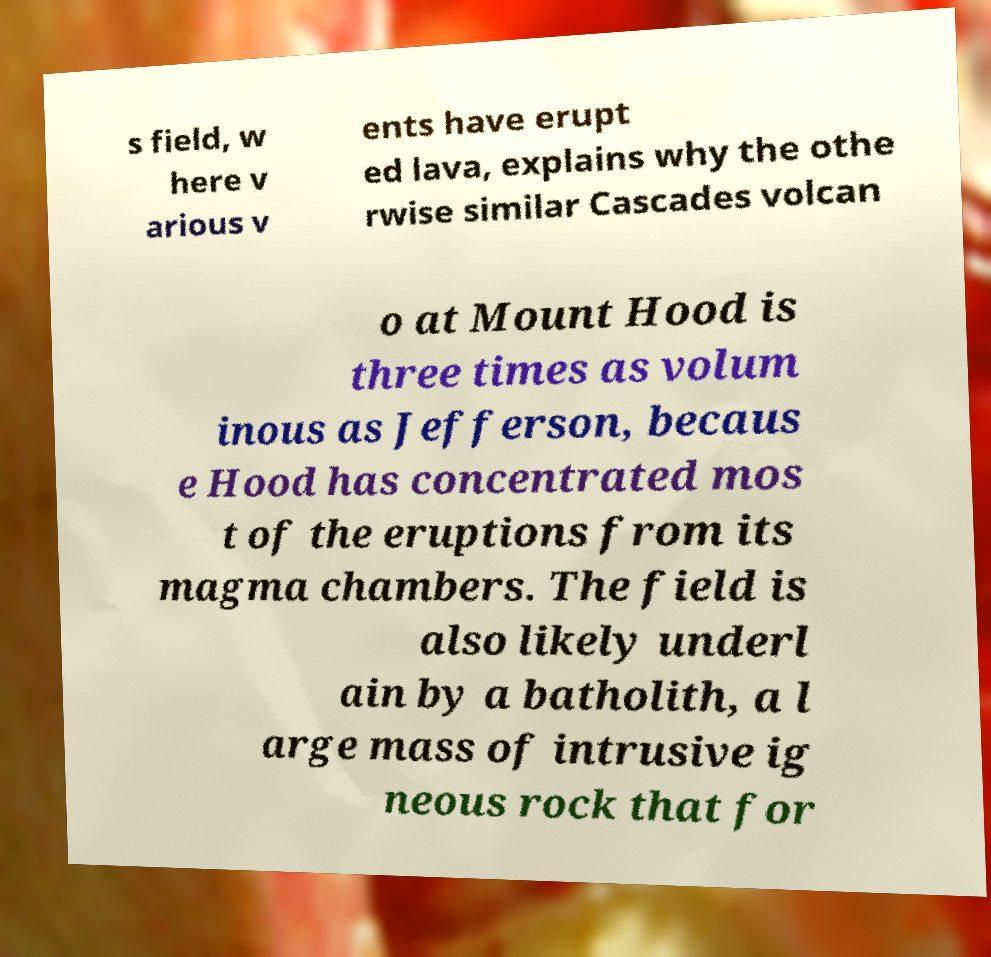Can you read and provide the text displayed in the image?This photo seems to have some interesting text. Can you extract and type it out for me? s field, w here v arious v ents have erupt ed lava, explains why the othe rwise similar Cascades volcan o at Mount Hood is three times as volum inous as Jefferson, becaus e Hood has concentrated mos t of the eruptions from its magma chambers. The field is also likely underl ain by a batholith, a l arge mass of intrusive ig neous rock that for 